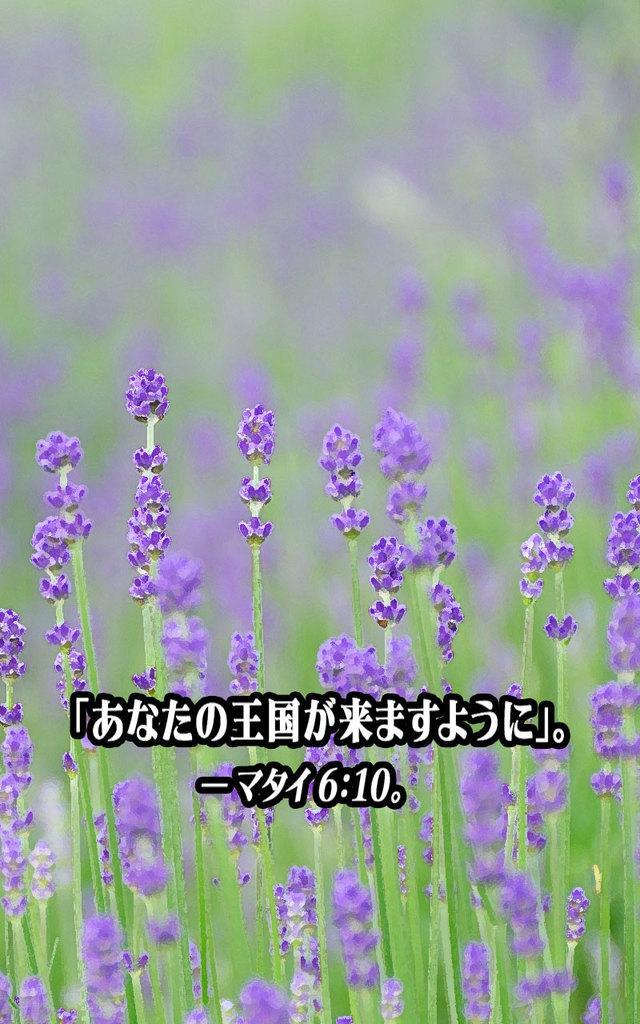In one or two sentences, can you explain what this image depicts? In this picture we can see there are plants with flowers. Behind the plants, there is the blurred background. On the image, there is a watermark. 